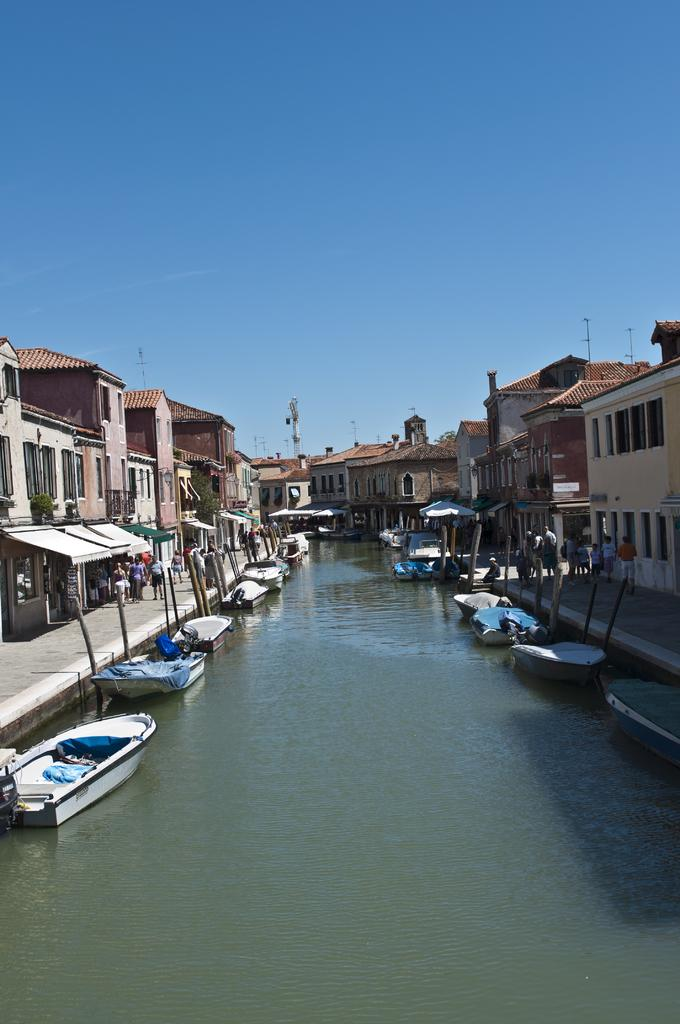What is on the water in the image? There are boats on the water in the image. What can be seen near the water in the image? People are present on the ground beside the water. What is visible in the background of the image? There are buildings, poles, and the sky visible in the background of the image. How much money is being exchanged between the people in the image? There is no indication of money being exchanged in the image. What type of breakfast is being served on the boats in the image? There are no boats serving breakfast in the image; it only shows boats on the water. 